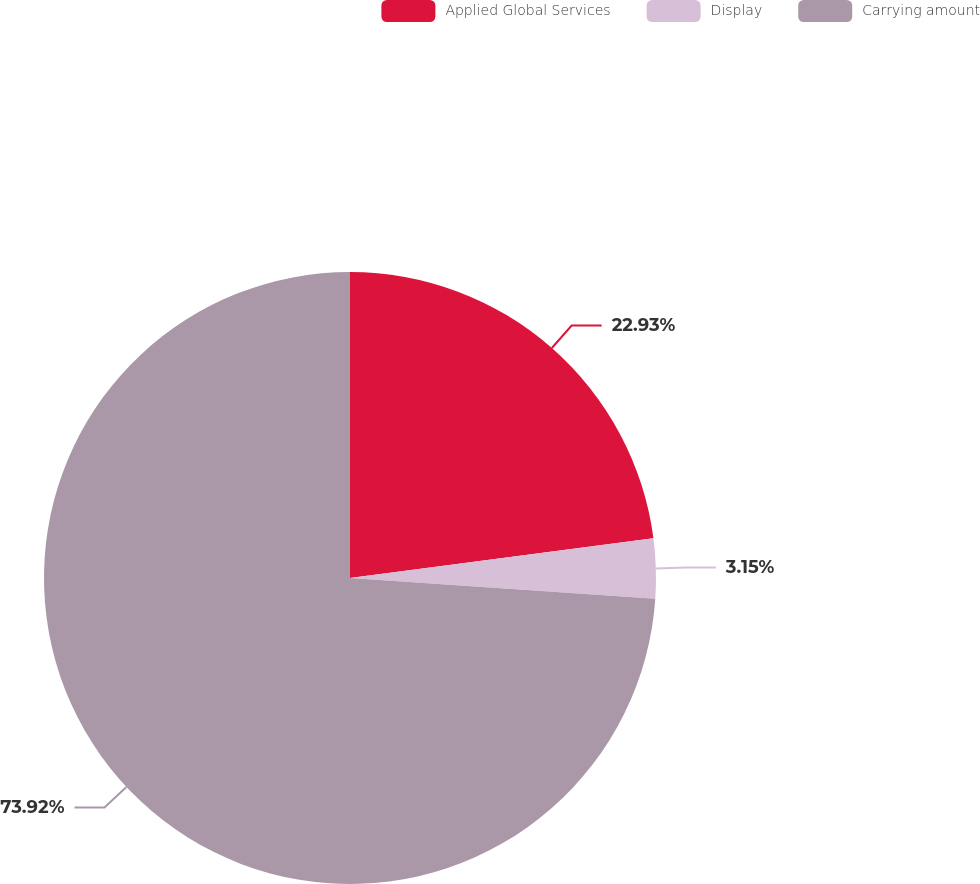Convert chart. <chart><loc_0><loc_0><loc_500><loc_500><pie_chart><fcel>Applied Global Services<fcel>Display<fcel>Carrying amount<nl><fcel>22.93%<fcel>3.15%<fcel>73.92%<nl></chart> 